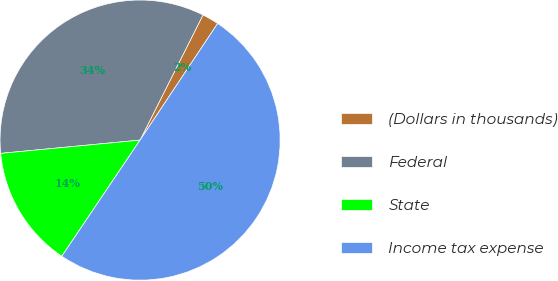Convert chart to OTSL. <chart><loc_0><loc_0><loc_500><loc_500><pie_chart><fcel>(Dollars in thousands)<fcel>Federal<fcel>State<fcel>Income tax expense<nl><fcel>1.93%<fcel>33.93%<fcel>14.05%<fcel>50.1%<nl></chart> 